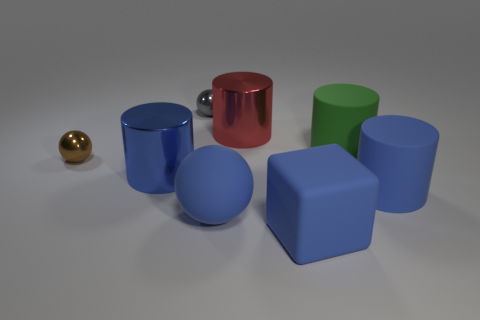There is a ball behind the green thing; does it have the same size as the brown ball?
Your answer should be very brief. Yes. What number of other objects are the same material as the gray object?
Your response must be concise. 3. Is the number of small metal things greater than the number of matte objects?
Ensure brevity in your answer.  No. What is the material of the large blue cylinder that is behind the large blue cylinder right of the sphere that is behind the small brown shiny sphere?
Provide a short and direct response. Metal. Are there any other large matte cubes of the same color as the matte block?
Give a very brief answer. No. There is a blue metallic object that is the same size as the green rubber cylinder; what shape is it?
Keep it short and to the point. Cylinder. Is the number of blue rubber objects less than the number of shiny things?
Your answer should be very brief. Yes. What number of blue matte blocks have the same size as the green cylinder?
Keep it short and to the point. 1. What is the shape of the shiny thing that is the same color as the cube?
Provide a short and direct response. Cylinder. What is the small brown ball made of?
Your response must be concise. Metal. 